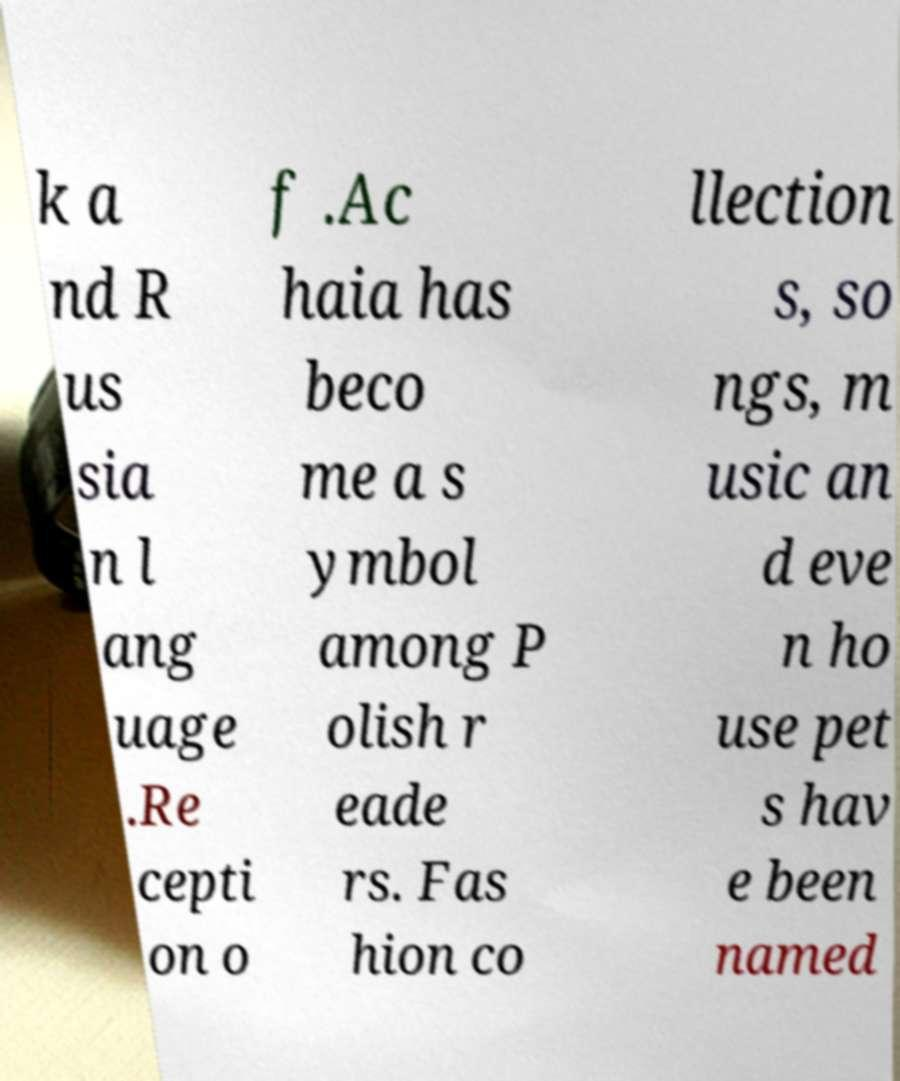Can you accurately transcribe the text from the provided image for me? k a nd R us sia n l ang uage .Re cepti on o f .Ac haia has beco me a s ymbol among P olish r eade rs. Fas hion co llection s, so ngs, m usic an d eve n ho use pet s hav e been named 